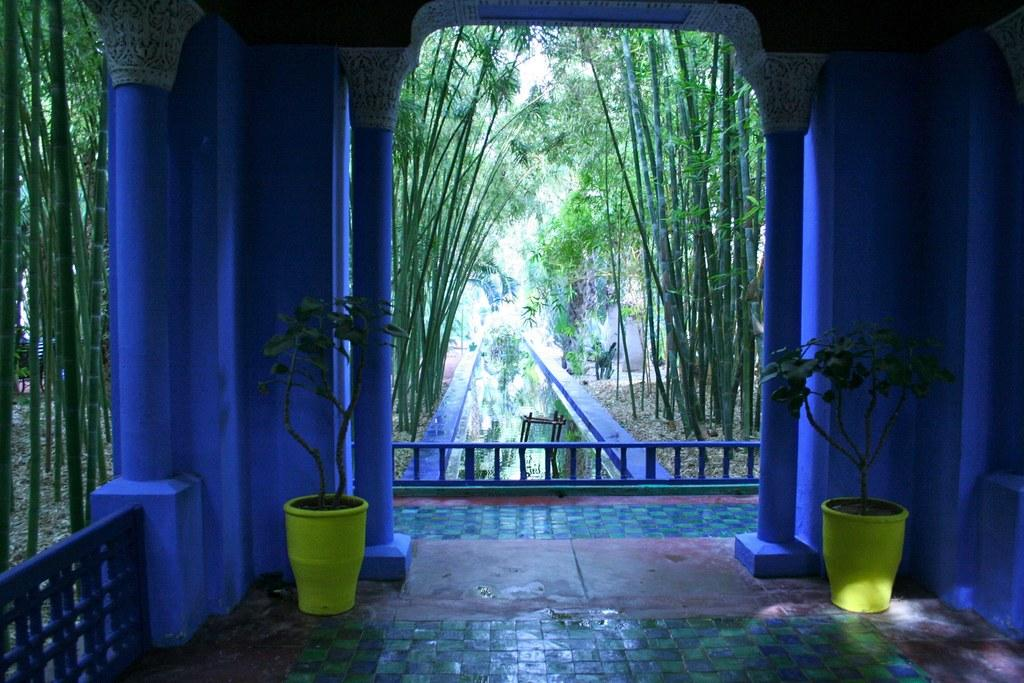What is the main structure visible in the image? There is a building in the image. What can be seen on the floor inside the building? There are two potted plants on the floor. Can you describe any other objects or features visible in the image? There are some other things visible in the image, but the specifics are not mentioned in the provided facts. What can be seen in the background of the image? There are trees in the background of the image. What type of thread is being used to process the regret in the image? There is no thread, regret, or process mentioned in the image. The image features a building, potted plants, and trees in the background. 